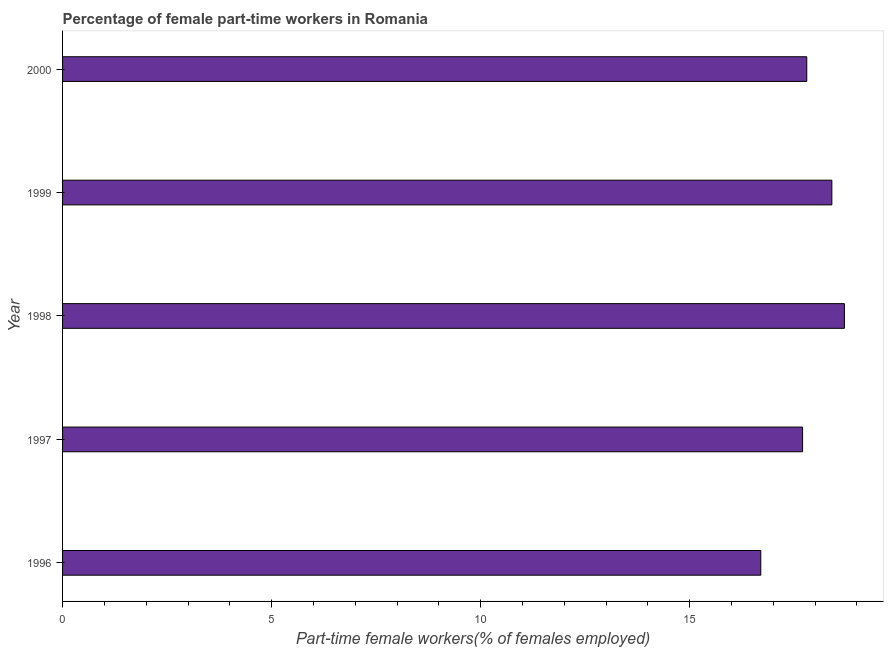Does the graph contain any zero values?
Your response must be concise. No. Does the graph contain grids?
Your response must be concise. No. What is the title of the graph?
Your answer should be compact. Percentage of female part-time workers in Romania. What is the label or title of the X-axis?
Offer a very short reply. Part-time female workers(% of females employed). What is the label or title of the Y-axis?
Provide a succinct answer. Year. What is the percentage of part-time female workers in 1999?
Your answer should be very brief. 18.4. Across all years, what is the maximum percentage of part-time female workers?
Offer a very short reply. 18.7. Across all years, what is the minimum percentage of part-time female workers?
Your answer should be very brief. 16.7. In which year was the percentage of part-time female workers minimum?
Give a very brief answer. 1996. What is the sum of the percentage of part-time female workers?
Give a very brief answer. 89.3. What is the difference between the percentage of part-time female workers in 1996 and 1997?
Your answer should be very brief. -1. What is the average percentage of part-time female workers per year?
Your answer should be compact. 17.86. What is the median percentage of part-time female workers?
Make the answer very short. 17.8. In how many years, is the percentage of part-time female workers greater than 16 %?
Ensure brevity in your answer.  5. What is the ratio of the percentage of part-time female workers in 1996 to that in 2000?
Make the answer very short. 0.94. Is the difference between the percentage of part-time female workers in 1996 and 1997 greater than the difference between any two years?
Your answer should be compact. No. What is the difference between the highest and the second highest percentage of part-time female workers?
Provide a short and direct response. 0.3. Is the sum of the percentage of part-time female workers in 1998 and 1999 greater than the maximum percentage of part-time female workers across all years?
Your answer should be compact. Yes. How many bars are there?
Keep it short and to the point. 5. How many years are there in the graph?
Offer a terse response. 5. Are the values on the major ticks of X-axis written in scientific E-notation?
Your answer should be very brief. No. What is the Part-time female workers(% of females employed) in 1996?
Provide a short and direct response. 16.7. What is the Part-time female workers(% of females employed) in 1997?
Offer a very short reply. 17.7. What is the Part-time female workers(% of females employed) in 1998?
Ensure brevity in your answer.  18.7. What is the Part-time female workers(% of females employed) of 1999?
Keep it short and to the point. 18.4. What is the Part-time female workers(% of females employed) of 2000?
Provide a short and direct response. 17.8. What is the difference between the Part-time female workers(% of females employed) in 1996 and 1997?
Provide a succinct answer. -1. What is the difference between the Part-time female workers(% of females employed) in 1996 and 1998?
Give a very brief answer. -2. What is the difference between the Part-time female workers(% of females employed) in 1997 and 1998?
Ensure brevity in your answer.  -1. What is the difference between the Part-time female workers(% of females employed) in 1997 and 1999?
Provide a succinct answer. -0.7. What is the difference between the Part-time female workers(% of females employed) in 1998 and 1999?
Keep it short and to the point. 0.3. What is the difference between the Part-time female workers(% of females employed) in 1998 and 2000?
Your answer should be very brief. 0.9. What is the difference between the Part-time female workers(% of females employed) in 1999 and 2000?
Your response must be concise. 0.6. What is the ratio of the Part-time female workers(% of females employed) in 1996 to that in 1997?
Your answer should be compact. 0.94. What is the ratio of the Part-time female workers(% of females employed) in 1996 to that in 1998?
Your answer should be compact. 0.89. What is the ratio of the Part-time female workers(% of females employed) in 1996 to that in 1999?
Provide a short and direct response. 0.91. What is the ratio of the Part-time female workers(% of females employed) in 1996 to that in 2000?
Ensure brevity in your answer.  0.94. What is the ratio of the Part-time female workers(% of females employed) in 1997 to that in 1998?
Your answer should be compact. 0.95. What is the ratio of the Part-time female workers(% of females employed) in 1997 to that in 1999?
Make the answer very short. 0.96. What is the ratio of the Part-time female workers(% of females employed) in 1998 to that in 2000?
Give a very brief answer. 1.05. What is the ratio of the Part-time female workers(% of females employed) in 1999 to that in 2000?
Make the answer very short. 1.03. 